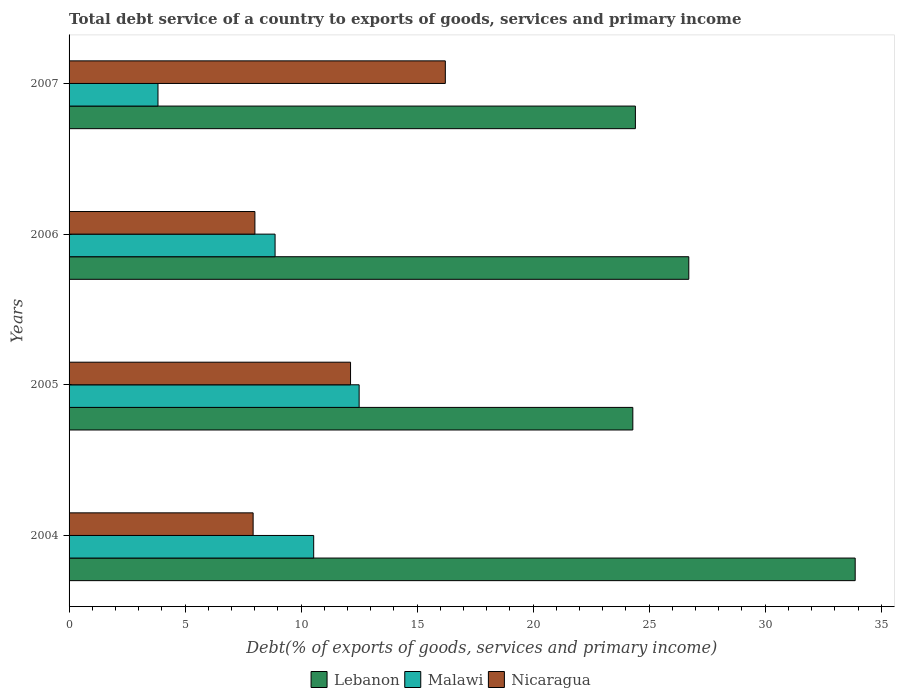How many groups of bars are there?
Ensure brevity in your answer.  4. Are the number of bars on each tick of the Y-axis equal?
Your response must be concise. Yes. What is the total debt service in Lebanon in 2004?
Keep it short and to the point. 33.88. Across all years, what is the maximum total debt service in Lebanon?
Offer a terse response. 33.88. Across all years, what is the minimum total debt service in Nicaragua?
Give a very brief answer. 7.93. In which year was the total debt service in Lebanon maximum?
Offer a terse response. 2004. What is the total total debt service in Lebanon in the graph?
Provide a short and direct response. 109.29. What is the difference between the total debt service in Lebanon in 2005 and that in 2006?
Provide a short and direct response. -2.41. What is the difference between the total debt service in Malawi in 2006 and the total debt service in Nicaragua in 2007?
Your answer should be compact. -7.34. What is the average total debt service in Malawi per year?
Make the answer very short. 8.94. In the year 2007, what is the difference between the total debt service in Lebanon and total debt service in Nicaragua?
Give a very brief answer. 8.19. In how many years, is the total debt service in Nicaragua greater than 1 %?
Your response must be concise. 4. What is the ratio of the total debt service in Nicaragua in 2004 to that in 2005?
Ensure brevity in your answer.  0.65. What is the difference between the highest and the second highest total debt service in Nicaragua?
Ensure brevity in your answer.  4.08. What is the difference between the highest and the lowest total debt service in Malawi?
Make the answer very short. 8.67. Is the sum of the total debt service in Lebanon in 2005 and 2007 greater than the maximum total debt service in Nicaragua across all years?
Offer a very short reply. Yes. What does the 2nd bar from the top in 2006 represents?
Your response must be concise. Malawi. What does the 1st bar from the bottom in 2004 represents?
Your response must be concise. Lebanon. How many bars are there?
Your response must be concise. 12. Are the values on the major ticks of X-axis written in scientific E-notation?
Provide a succinct answer. No. Does the graph contain grids?
Your answer should be very brief. No. Where does the legend appear in the graph?
Your answer should be very brief. Bottom center. How many legend labels are there?
Your answer should be compact. 3. How are the legend labels stacked?
Give a very brief answer. Horizontal. What is the title of the graph?
Offer a terse response. Total debt service of a country to exports of goods, services and primary income. What is the label or title of the X-axis?
Give a very brief answer. Debt(% of exports of goods, services and primary income). What is the label or title of the Y-axis?
Provide a succinct answer. Years. What is the Debt(% of exports of goods, services and primary income) of Lebanon in 2004?
Your answer should be compact. 33.88. What is the Debt(% of exports of goods, services and primary income) in Malawi in 2004?
Offer a very short reply. 10.54. What is the Debt(% of exports of goods, services and primary income) in Nicaragua in 2004?
Ensure brevity in your answer.  7.93. What is the Debt(% of exports of goods, services and primary income) of Lebanon in 2005?
Offer a terse response. 24.3. What is the Debt(% of exports of goods, services and primary income) in Malawi in 2005?
Your answer should be very brief. 12.5. What is the Debt(% of exports of goods, services and primary income) of Nicaragua in 2005?
Your answer should be compact. 12.13. What is the Debt(% of exports of goods, services and primary income) in Lebanon in 2006?
Your answer should be very brief. 26.71. What is the Debt(% of exports of goods, services and primary income) of Malawi in 2006?
Provide a short and direct response. 8.88. What is the Debt(% of exports of goods, services and primary income) of Nicaragua in 2006?
Your response must be concise. 8.01. What is the Debt(% of exports of goods, services and primary income) in Lebanon in 2007?
Offer a very short reply. 24.41. What is the Debt(% of exports of goods, services and primary income) of Malawi in 2007?
Ensure brevity in your answer.  3.83. What is the Debt(% of exports of goods, services and primary income) in Nicaragua in 2007?
Make the answer very short. 16.22. Across all years, what is the maximum Debt(% of exports of goods, services and primary income) in Lebanon?
Keep it short and to the point. 33.88. Across all years, what is the maximum Debt(% of exports of goods, services and primary income) in Malawi?
Provide a succinct answer. 12.5. Across all years, what is the maximum Debt(% of exports of goods, services and primary income) of Nicaragua?
Your answer should be compact. 16.22. Across all years, what is the minimum Debt(% of exports of goods, services and primary income) of Lebanon?
Ensure brevity in your answer.  24.3. Across all years, what is the minimum Debt(% of exports of goods, services and primary income) in Malawi?
Keep it short and to the point. 3.83. Across all years, what is the minimum Debt(% of exports of goods, services and primary income) of Nicaragua?
Ensure brevity in your answer.  7.93. What is the total Debt(% of exports of goods, services and primary income) of Lebanon in the graph?
Offer a very short reply. 109.29. What is the total Debt(% of exports of goods, services and primary income) of Malawi in the graph?
Make the answer very short. 35.75. What is the total Debt(% of exports of goods, services and primary income) of Nicaragua in the graph?
Provide a succinct answer. 44.29. What is the difference between the Debt(% of exports of goods, services and primary income) of Lebanon in 2004 and that in 2005?
Your answer should be very brief. 9.58. What is the difference between the Debt(% of exports of goods, services and primary income) in Malawi in 2004 and that in 2005?
Keep it short and to the point. -1.96. What is the difference between the Debt(% of exports of goods, services and primary income) of Nicaragua in 2004 and that in 2005?
Provide a succinct answer. -4.2. What is the difference between the Debt(% of exports of goods, services and primary income) in Lebanon in 2004 and that in 2006?
Your answer should be very brief. 7.17. What is the difference between the Debt(% of exports of goods, services and primary income) of Malawi in 2004 and that in 2006?
Ensure brevity in your answer.  1.66. What is the difference between the Debt(% of exports of goods, services and primary income) of Nicaragua in 2004 and that in 2006?
Offer a terse response. -0.08. What is the difference between the Debt(% of exports of goods, services and primary income) of Lebanon in 2004 and that in 2007?
Provide a succinct answer. 9.47. What is the difference between the Debt(% of exports of goods, services and primary income) in Malawi in 2004 and that in 2007?
Make the answer very short. 6.71. What is the difference between the Debt(% of exports of goods, services and primary income) of Nicaragua in 2004 and that in 2007?
Give a very brief answer. -8.28. What is the difference between the Debt(% of exports of goods, services and primary income) of Lebanon in 2005 and that in 2006?
Give a very brief answer. -2.41. What is the difference between the Debt(% of exports of goods, services and primary income) in Malawi in 2005 and that in 2006?
Provide a short and direct response. 3.62. What is the difference between the Debt(% of exports of goods, services and primary income) in Nicaragua in 2005 and that in 2006?
Provide a short and direct response. 4.12. What is the difference between the Debt(% of exports of goods, services and primary income) of Lebanon in 2005 and that in 2007?
Your answer should be very brief. -0.11. What is the difference between the Debt(% of exports of goods, services and primary income) in Malawi in 2005 and that in 2007?
Give a very brief answer. 8.67. What is the difference between the Debt(% of exports of goods, services and primary income) in Nicaragua in 2005 and that in 2007?
Make the answer very short. -4.08. What is the difference between the Debt(% of exports of goods, services and primary income) of Lebanon in 2006 and that in 2007?
Give a very brief answer. 2.3. What is the difference between the Debt(% of exports of goods, services and primary income) in Malawi in 2006 and that in 2007?
Offer a very short reply. 5.05. What is the difference between the Debt(% of exports of goods, services and primary income) of Nicaragua in 2006 and that in 2007?
Provide a short and direct response. -8.21. What is the difference between the Debt(% of exports of goods, services and primary income) in Lebanon in 2004 and the Debt(% of exports of goods, services and primary income) in Malawi in 2005?
Make the answer very short. 21.38. What is the difference between the Debt(% of exports of goods, services and primary income) in Lebanon in 2004 and the Debt(% of exports of goods, services and primary income) in Nicaragua in 2005?
Your answer should be very brief. 21.75. What is the difference between the Debt(% of exports of goods, services and primary income) in Malawi in 2004 and the Debt(% of exports of goods, services and primary income) in Nicaragua in 2005?
Provide a short and direct response. -1.59. What is the difference between the Debt(% of exports of goods, services and primary income) of Lebanon in 2004 and the Debt(% of exports of goods, services and primary income) of Malawi in 2006?
Provide a succinct answer. 25. What is the difference between the Debt(% of exports of goods, services and primary income) in Lebanon in 2004 and the Debt(% of exports of goods, services and primary income) in Nicaragua in 2006?
Your answer should be compact. 25.87. What is the difference between the Debt(% of exports of goods, services and primary income) of Malawi in 2004 and the Debt(% of exports of goods, services and primary income) of Nicaragua in 2006?
Your answer should be compact. 2.53. What is the difference between the Debt(% of exports of goods, services and primary income) in Lebanon in 2004 and the Debt(% of exports of goods, services and primary income) in Malawi in 2007?
Your answer should be very brief. 30.05. What is the difference between the Debt(% of exports of goods, services and primary income) in Lebanon in 2004 and the Debt(% of exports of goods, services and primary income) in Nicaragua in 2007?
Your answer should be compact. 17.66. What is the difference between the Debt(% of exports of goods, services and primary income) of Malawi in 2004 and the Debt(% of exports of goods, services and primary income) of Nicaragua in 2007?
Keep it short and to the point. -5.67. What is the difference between the Debt(% of exports of goods, services and primary income) of Lebanon in 2005 and the Debt(% of exports of goods, services and primary income) of Malawi in 2006?
Ensure brevity in your answer.  15.42. What is the difference between the Debt(% of exports of goods, services and primary income) of Lebanon in 2005 and the Debt(% of exports of goods, services and primary income) of Nicaragua in 2006?
Provide a succinct answer. 16.29. What is the difference between the Debt(% of exports of goods, services and primary income) of Malawi in 2005 and the Debt(% of exports of goods, services and primary income) of Nicaragua in 2006?
Keep it short and to the point. 4.49. What is the difference between the Debt(% of exports of goods, services and primary income) in Lebanon in 2005 and the Debt(% of exports of goods, services and primary income) in Malawi in 2007?
Offer a very short reply. 20.46. What is the difference between the Debt(% of exports of goods, services and primary income) in Lebanon in 2005 and the Debt(% of exports of goods, services and primary income) in Nicaragua in 2007?
Your answer should be compact. 8.08. What is the difference between the Debt(% of exports of goods, services and primary income) of Malawi in 2005 and the Debt(% of exports of goods, services and primary income) of Nicaragua in 2007?
Provide a short and direct response. -3.71. What is the difference between the Debt(% of exports of goods, services and primary income) in Lebanon in 2006 and the Debt(% of exports of goods, services and primary income) in Malawi in 2007?
Offer a very short reply. 22.88. What is the difference between the Debt(% of exports of goods, services and primary income) of Lebanon in 2006 and the Debt(% of exports of goods, services and primary income) of Nicaragua in 2007?
Provide a short and direct response. 10.49. What is the difference between the Debt(% of exports of goods, services and primary income) of Malawi in 2006 and the Debt(% of exports of goods, services and primary income) of Nicaragua in 2007?
Your answer should be very brief. -7.34. What is the average Debt(% of exports of goods, services and primary income) of Lebanon per year?
Your answer should be compact. 27.32. What is the average Debt(% of exports of goods, services and primary income) of Malawi per year?
Make the answer very short. 8.94. What is the average Debt(% of exports of goods, services and primary income) in Nicaragua per year?
Keep it short and to the point. 11.07. In the year 2004, what is the difference between the Debt(% of exports of goods, services and primary income) of Lebanon and Debt(% of exports of goods, services and primary income) of Malawi?
Give a very brief answer. 23.34. In the year 2004, what is the difference between the Debt(% of exports of goods, services and primary income) in Lebanon and Debt(% of exports of goods, services and primary income) in Nicaragua?
Give a very brief answer. 25.95. In the year 2004, what is the difference between the Debt(% of exports of goods, services and primary income) of Malawi and Debt(% of exports of goods, services and primary income) of Nicaragua?
Give a very brief answer. 2.61. In the year 2005, what is the difference between the Debt(% of exports of goods, services and primary income) of Lebanon and Debt(% of exports of goods, services and primary income) of Malawi?
Keep it short and to the point. 11.79. In the year 2005, what is the difference between the Debt(% of exports of goods, services and primary income) of Lebanon and Debt(% of exports of goods, services and primary income) of Nicaragua?
Keep it short and to the point. 12.17. In the year 2005, what is the difference between the Debt(% of exports of goods, services and primary income) of Malawi and Debt(% of exports of goods, services and primary income) of Nicaragua?
Your answer should be very brief. 0.37. In the year 2006, what is the difference between the Debt(% of exports of goods, services and primary income) in Lebanon and Debt(% of exports of goods, services and primary income) in Malawi?
Make the answer very short. 17.83. In the year 2006, what is the difference between the Debt(% of exports of goods, services and primary income) in Lebanon and Debt(% of exports of goods, services and primary income) in Nicaragua?
Give a very brief answer. 18.7. In the year 2006, what is the difference between the Debt(% of exports of goods, services and primary income) in Malawi and Debt(% of exports of goods, services and primary income) in Nicaragua?
Your answer should be very brief. 0.87. In the year 2007, what is the difference between the Debt(% of exports of goods, services and primary income) in Lebanon and Debt(% of exports of goods, services and primary income) in Malawi?
Provide a short and direct response. 20.57. In the year 2007, what is the difference between the Debt(% of exports of goods, services and primary income) in Lebanon and Debt(% of exports of goods, services and primary income) in Nicaragua?
Offer a very short reply. 8.19. In the year 2007, what is the difference between the Debt(% of exports of goods, services and primary income) in Malawi and Debt(% of exports of goods, services and primary income) in Nicaragua?
Provide a succinct answer. -12.38. What is the ratio of the Debt(% of exports of goods, services and primary income) of Lebanon in 2004 to that in 2005?
Provide a succinct answer. 1.39. What is the ratio of the Debt(% of exports of goods, services and primary income) in Malawi in 2004 to that in 2005?
Ensure brevity in your answer.  0.84. What is the ratio of the Debt(% of exports of goods, services and primary income) in Nicaragua in 2004 to that in 2005?
Your response must be concise. 0.65. What is the ratio of the Debt(% of exports of goods, services and primary income) in Lebanon in 2004 to that in 2006?
Ensure brevity in your answer.  1.27. What is the ratio of the Debt(% of exports of goods, services and primary income) in Malawi in 2004 to that in 2006?
Keep it short and to the point. 1.19. What is the ratio of the Debt(% of exports of goods, services and primary income) in Nicaragua in 2004 to that in 2006?
Make the answer very short. 0.99. What is the ratio of the Debt(% of exports of goods, services and primary income) of Lebanon in 2004 to that in 2007?
Keep it short and to the point. 1.39. What is the ratio of the Debt(% of exports of goods, services and primary income) in Malawi in 2004 to that in 2007?
Your response must be concise. 2.75. What is the ratio of the Debt(% of exports of goods, services and primary income) of Nicaragua in 2004 to that in 2007?
Your response must be concise. 0.49. What is the ratio of the Debt(% of exports of goods, services and primary income) of Lebanon in 2005 to that in 2006?
Provide a short and direct response. 0.91. What is the ratio of the Debt(% of exports of goods, services and primary income) of Malawi in 2005 to that in 2006?
Offer a very short reply. 1.41. What is the ratio of the Debt(% of exports of goods, services and primary income) of Nicaragua in 2005 to that in 2006?
Offer a terse response. 1.51. What is the ratio of the Debt(% of exports of goods, services and primary income) of Lebanon in 2005 to that in 2007?
Offer a terse response. 1. What is the ratio of the Debt(% of exports of goods, services and primary income) in Malawi in 2005 to that in 2007?
Make the answer very short. 3.26. What is the ratio of the Debt(% of exports of goods, services and primary income) of Nicaragua in 2005 to that in 2007?
Provide a short and direct response. 0.75. What is the ratio of the Debt(% of exports of goods, services and primary income) in Lebanon in 2006 to that in 2007?
Keep it short and to the point. 1.09. What is the ratio of the Debt(% of exports of goods, services and primary income) in Malawi in 2006 to that in 2007?
Your answer should be very brief. 2.32. What is the ratio of the Debt(% of exports of goods, services and primary income) in Nicaragua in 2006 to that in 2007?
Ensure brevity in your answer.  0.49. What is the difference between the highest and the second highest Debt(% of exports of goods, services and primary income) of Lebanon?
Give a very brief answer. 7.17. What is the difference between the highest and the second highest Debt(% of exports of goods, services and primary income) in Malawi?
Ensure brevity in your answer.  1.96. What is the difference between the highest and the second highest Debt(% of exports of goods, services and primary income) of Nicaragua?
Provide a short and direct response. 4.08. What is the difference between the highest and the lowest Debt(% of exports of goods, services and primary income) of Lebanon?
Provide a short and direct response. 9.58. What is the difference between the highest and the lowest Debt(% of exports of goods, services and primary income) in Malawi?
Make the answer very short. 8.67. What is the difference between the highest and the lowest Debt(% of exports of goods, services and primary income) in Nicaragua?
Ensure brevity in your answer.  8.28. 